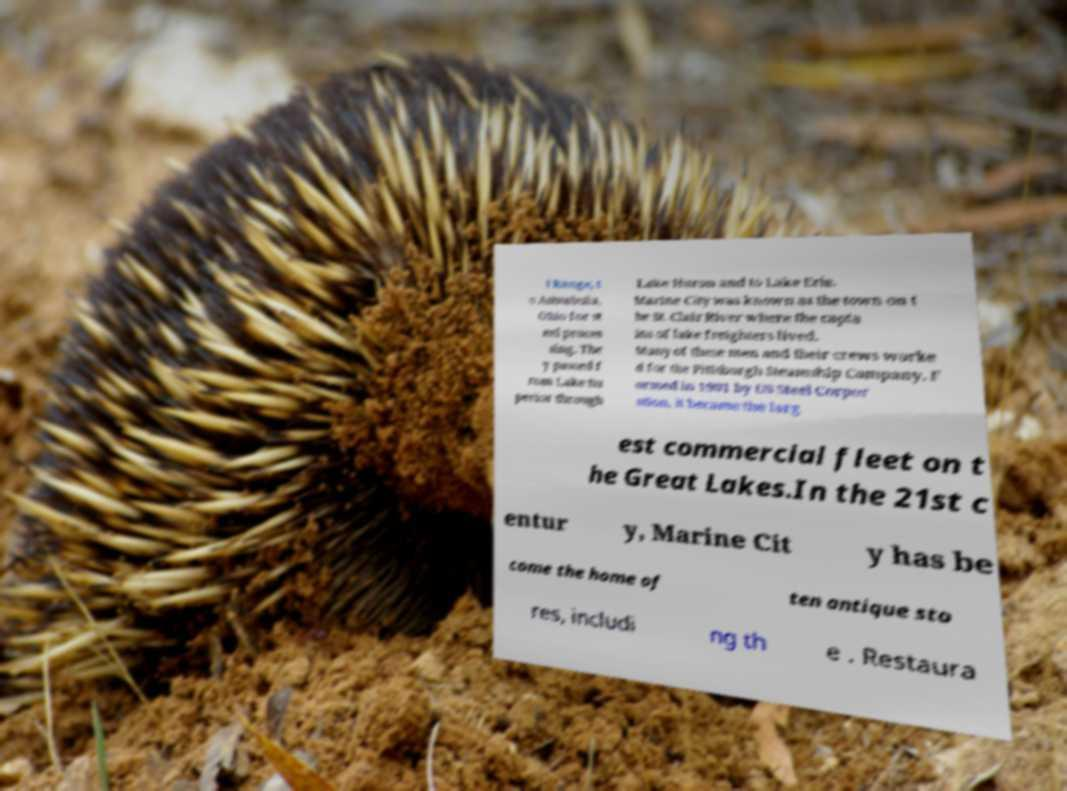Can you read and provide the text displayed in the image?This photo seems to have some interesting text. Can you extract and type it out for me? i Range, t o Ashtabula, Ohio for st eel proces sing. The y passed f rom Lake Su perior through Lake Huron and to Lake Erie. Marine City was known as the town on t he St. Clair River where the capta ins of lake freighters lived. Many of these men and their crews worke d for the Pittsburgh Steamship Company. F ormed in 1901 by US Steel Corpor ation, it became the larg est commercial fleet on t he Great Lakes.In the 21st c entur y, Marine Cit y has be come the home of ten antique sto res, includi ng th e . Restaura 